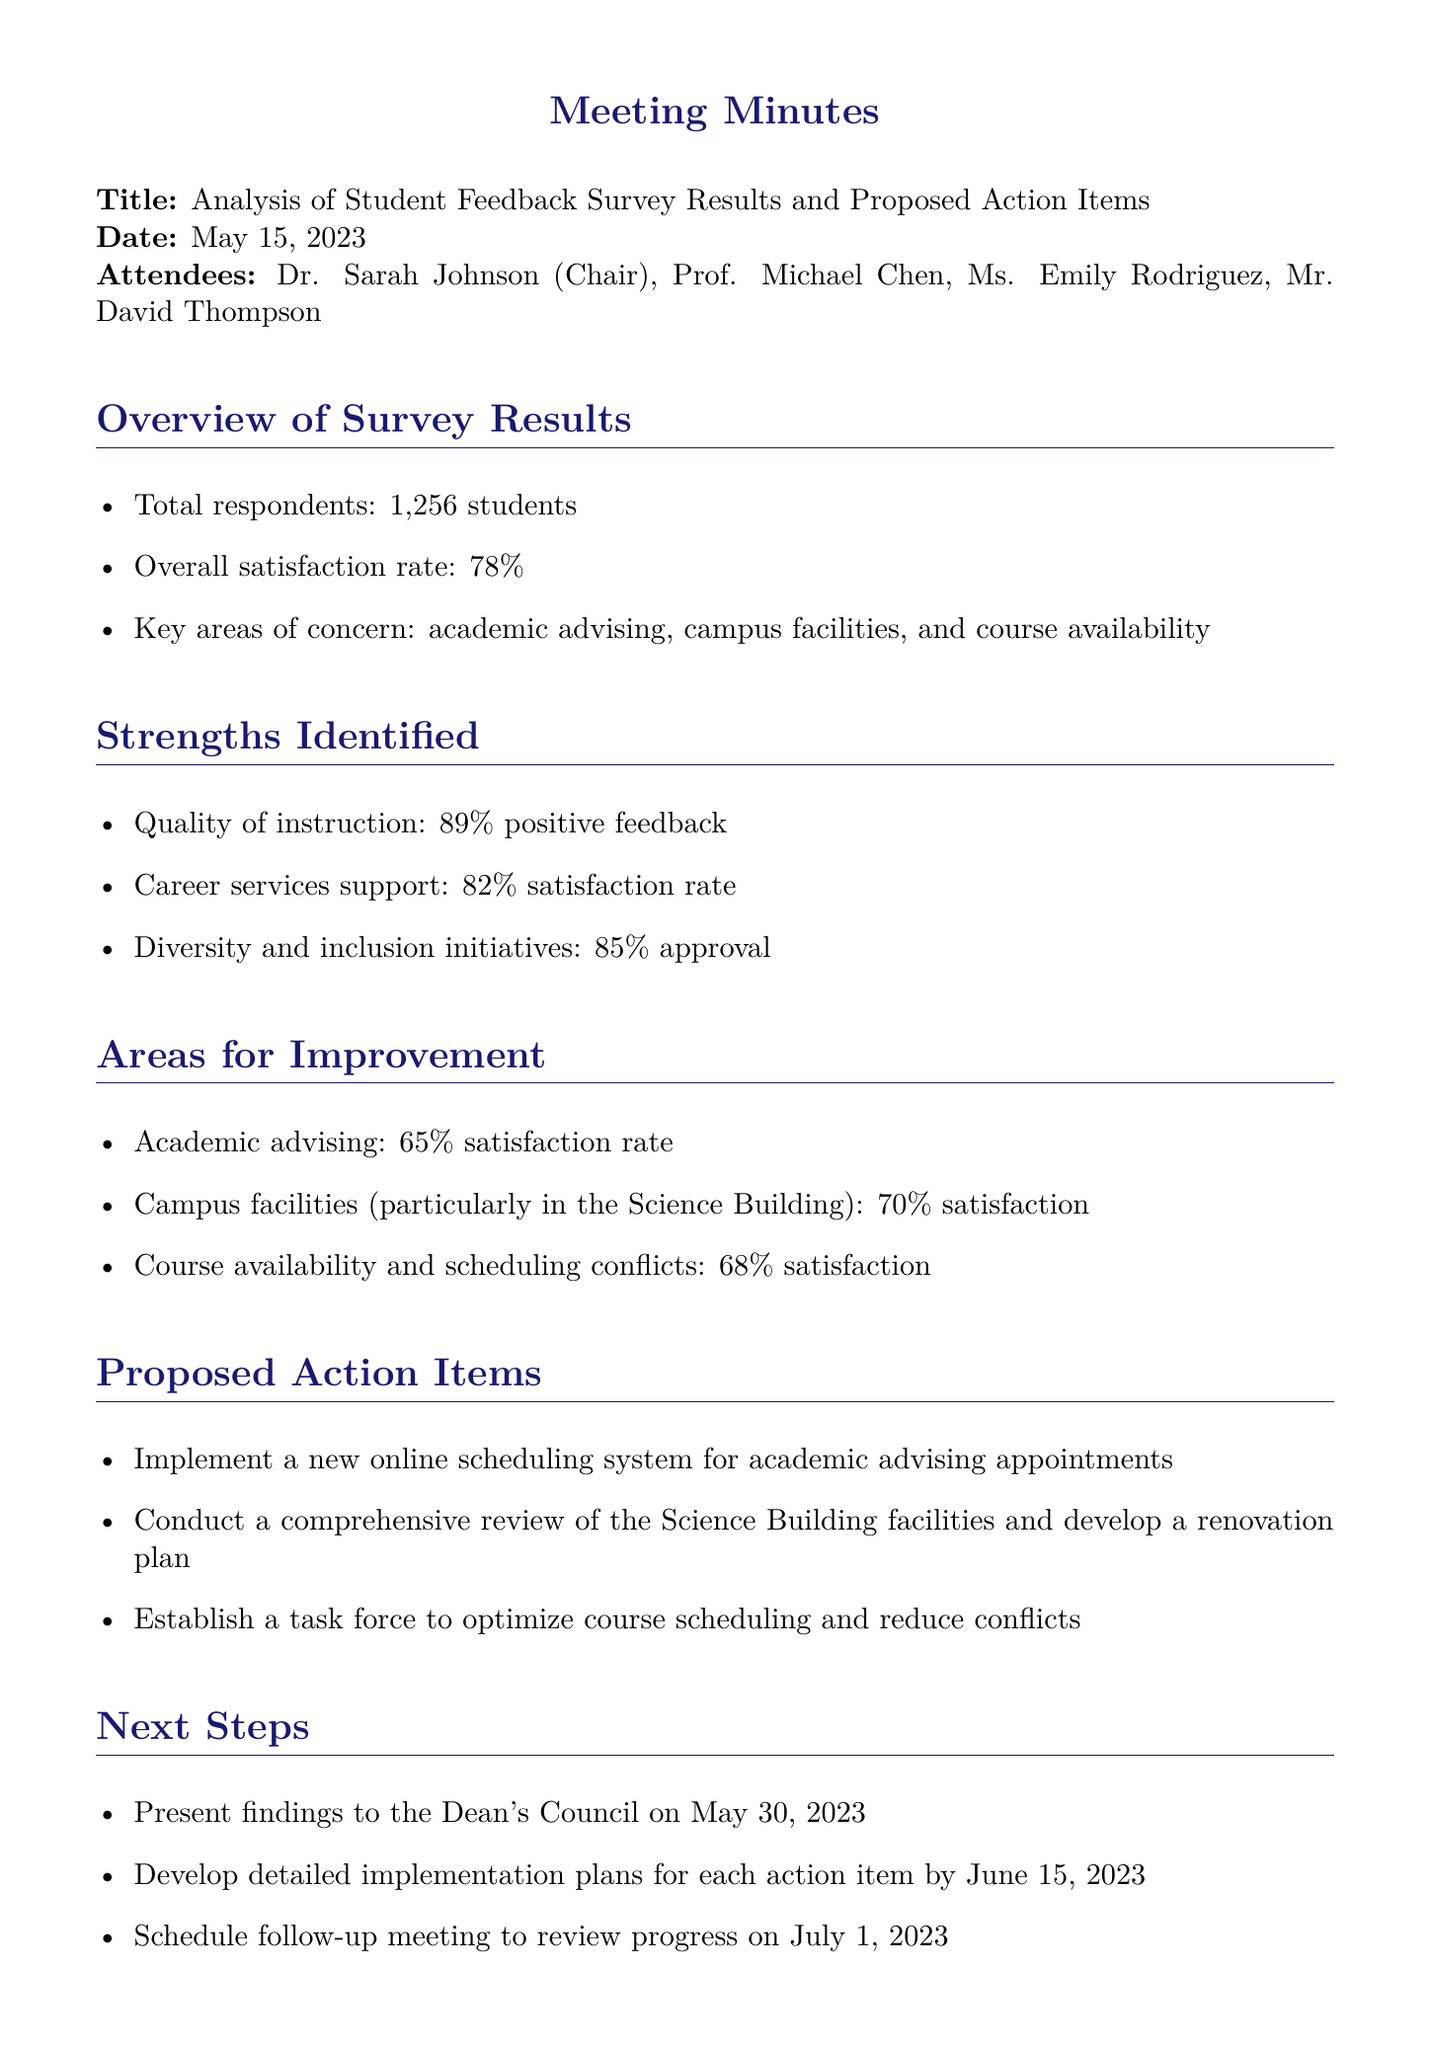What was the overall satisfaction rate of the students? The overall satisfaction rate indicates how satisfied the respondents were with the overall experience at the institution, which is stated as 78%.
Answer: 78% How many students responded to the survey? This number is a direct statistic from the document indicating the total number of respondents, which is 1,256 students.
Answer: 1,256 students What is the satisfaction rate for academic advising? This is found in the section detailing areas for improvement, indicating how satisfied students are with academic advising, which is stated as 65%.
Answer: 65% Which area received the highest positive feedback? This question focuses on the strengths identified in the survey results, which states the quality of instruction received 89% positive feedback.
Answer: Quality of instruction When will the findings be presented to the Dean's Council? This is a specific date mentioned under next steps, which details the timeline for actions proposed from the survey results, set for May 30, 2023.
Answer: May 30, 2023 What action will be taken to address course scheduling conflicts? This asks for a specific action item proposed to solve an issue identified in the survey results regarding course scheduling conflicts mentioned in the document, which is to establish a task force.
Answer: Establish a task force What percentage of students expressed satisfaction with career services support? This focuses on specific feedback regarding career services support mentioned in the strengths section of the document, which is 82%.
Answer: 82% Who chaired the meeting? This identifies the individual leading the meeting, as noted in the attendance list, which is Dr. Sarah Johnson.
Answer: Dr. Sarah Johnson 